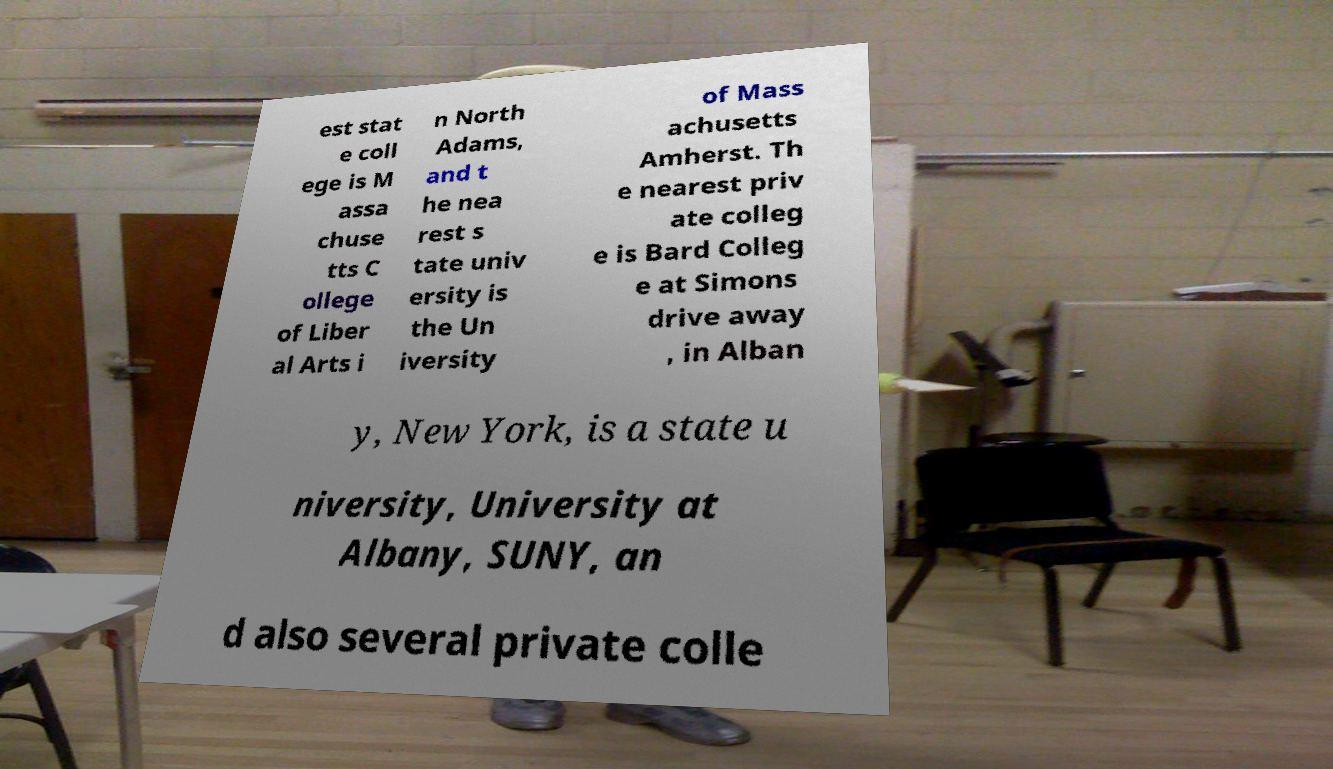Can you accurately transcribe the text from the provided image for me? est stat e coll ege is M assa chuse tts C ollege of Liber al Arts i n North Adams, and t he nea rest s tate univ ersity is the Un iversity of Mass achusetts Amherst. Th e nearest priv ate colleg e is Bard Colleg e at Simons drive away , in Alban y, New York, is a state u niversity, University at Albany, SUNY, an d also several private colle 